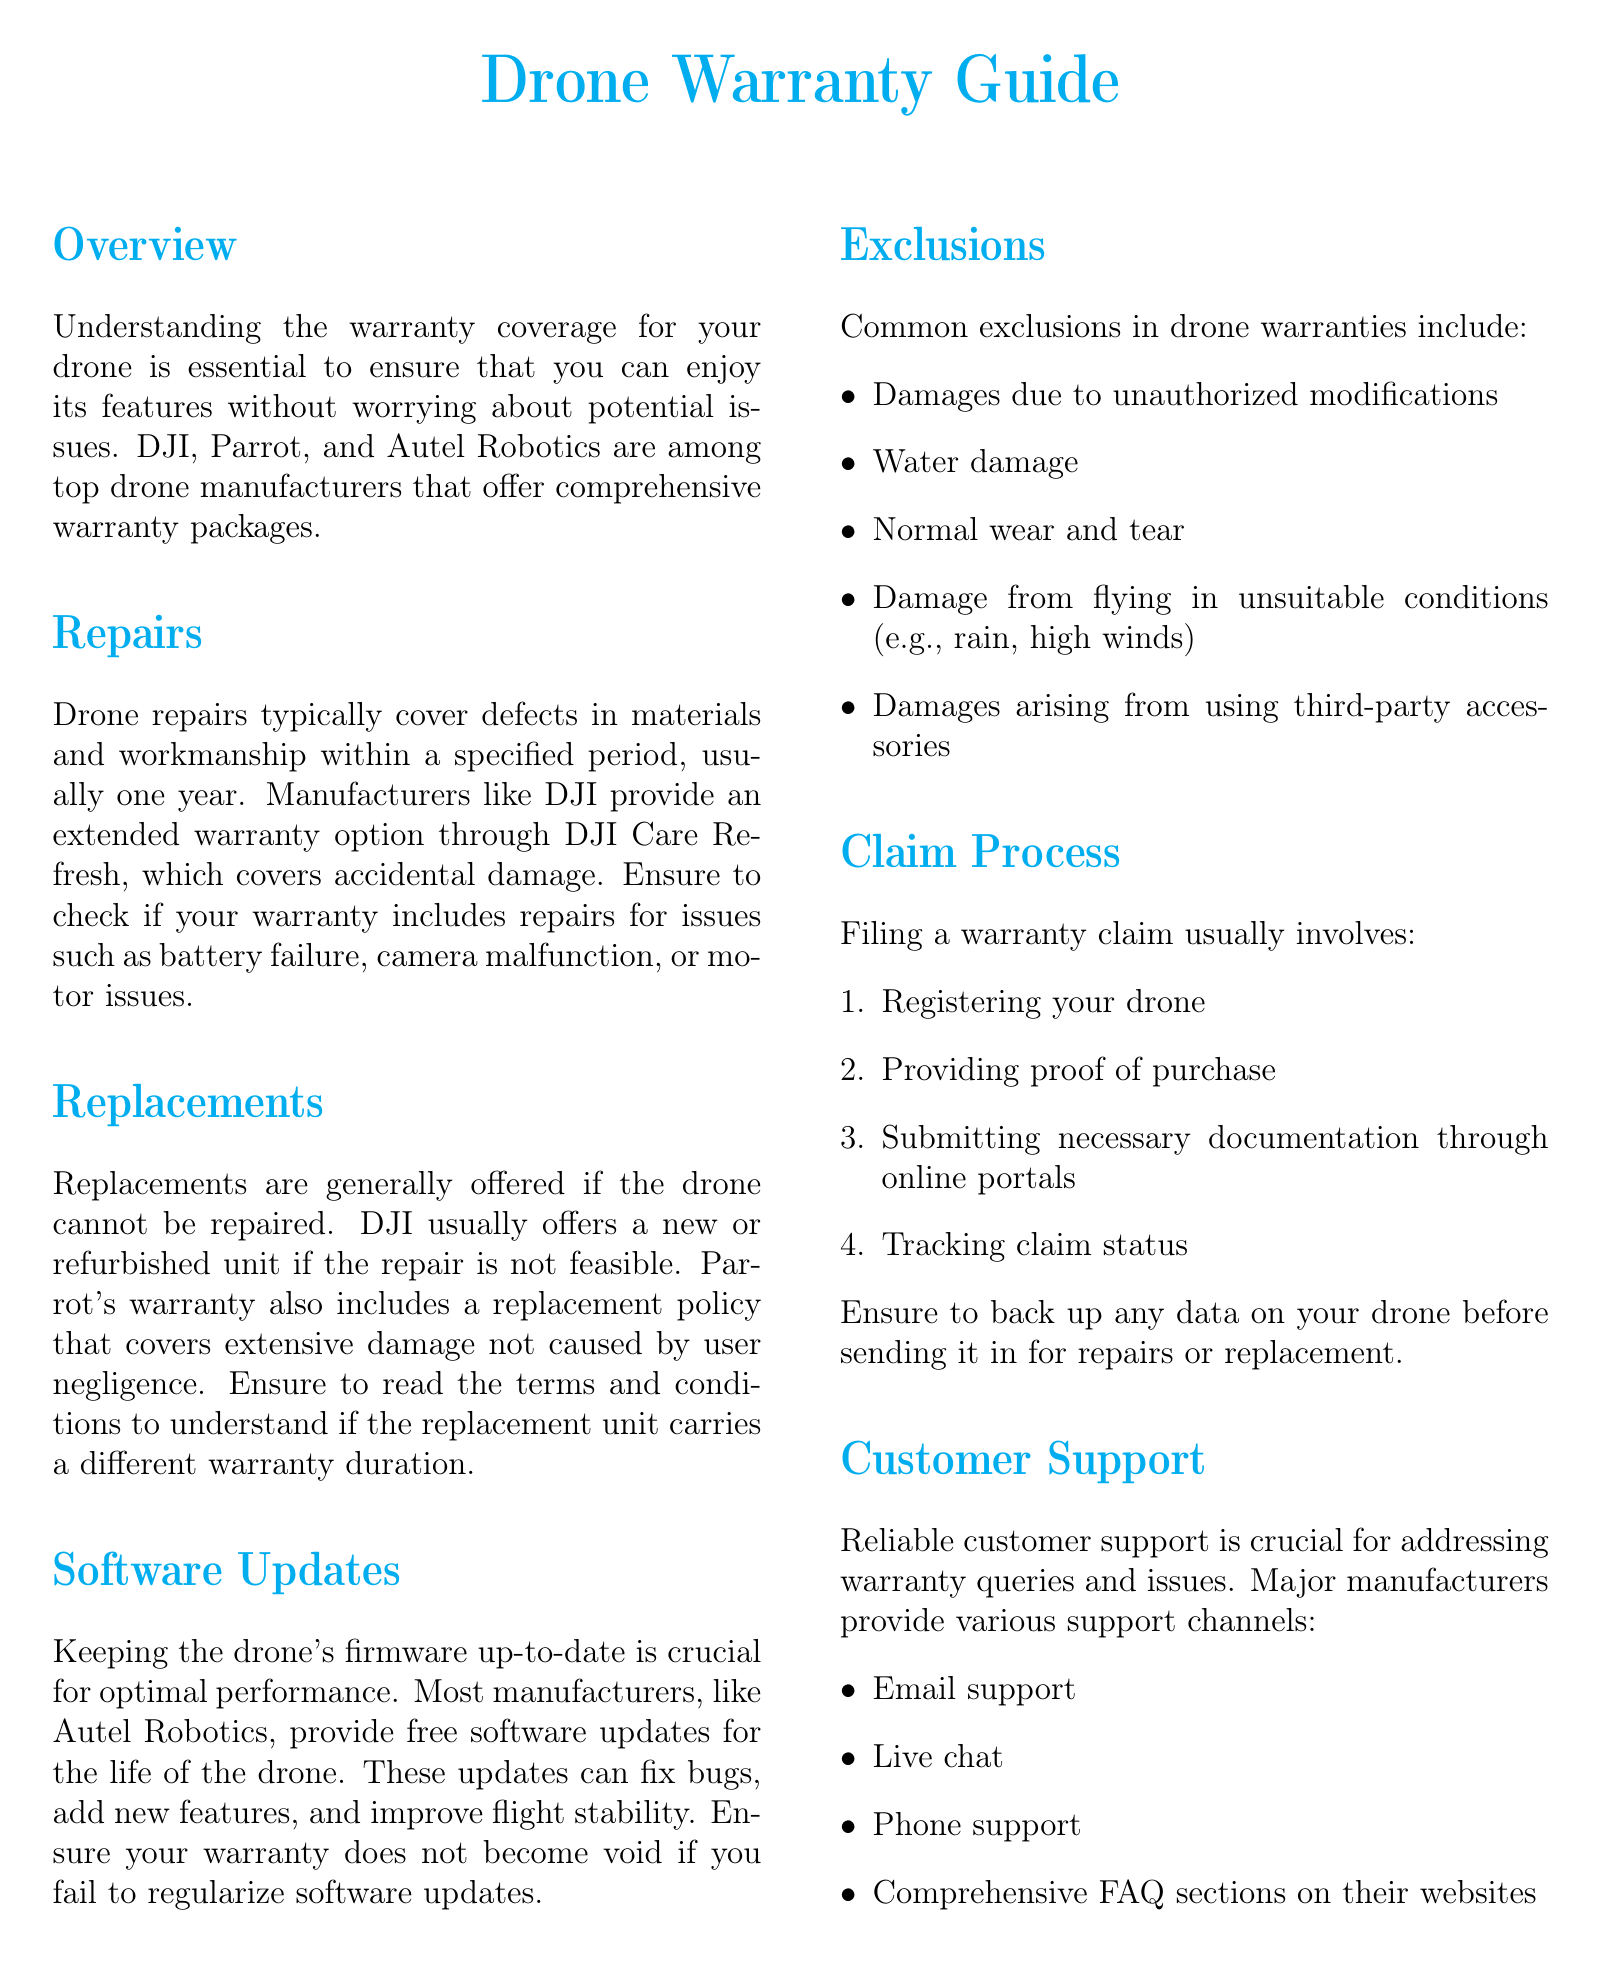What is the typical warranty period for drone repairs? The typical warranty period for drone repairs is usually one year.
Answer: one year Which manufacturer offers an extended warranty option called DJI Care Refresh? The manufacturer that offers an extended warranty option called DJI Care Refresh is DJI.
Answer: DJI What kind of damages are generally excluded from drone warranties? Common exclusions in drone warranties include damages due to unauthorized modifications.
Answer: unauthorized modifications What is necessary to file a warranty claim? Filing a warranty claim usually involves providing proof of purchase.
Answer: proof of purchase Which manufacturer provides free software updates for the life of the drone? The manufacturer that provides free software updates for the life of the drone is Autel Robotics.
Answer: Autel Robotics What should you do before sending your drone for repairs? You should back up any data on your drone before sending it in for repairs or replacement.
Answer: back up data What type of support channels do major manufacturers provide? Major manufacturers provide support channels like email support.
Answer: email support What happens if a drone cannot be repaired? If a drone cannot be repaired, manufacturers like DJI usually offer a new or refurbished unit.
Answer: new or refurbished unit 